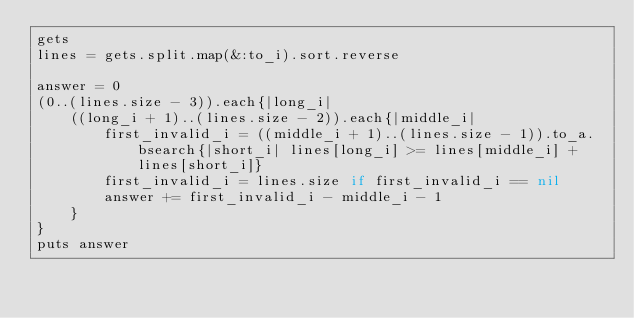<code> <loc_0><loc_0><loc_500><loc_500><_Ruby_>gets
lines = gets.split.map(&:to_i).sort.reverse

answer = 0
(0..(lines.size - 3)).each{|long_i|
    ((long_i + 1)..(lines.size - 2)).each{|middle_i|
        first_invalid_i = ((middle_i + 1)..(lines.size - 1)).to_a.bsearch{|short_i| lines[long_i] >= lines[middle_i] + lines[short_i]}
        first_invalid_i = lines.size if first_invalid_i == nil
        answer += first_invalid_i - middle_i - 1
    }
}
puts answer
</code> 